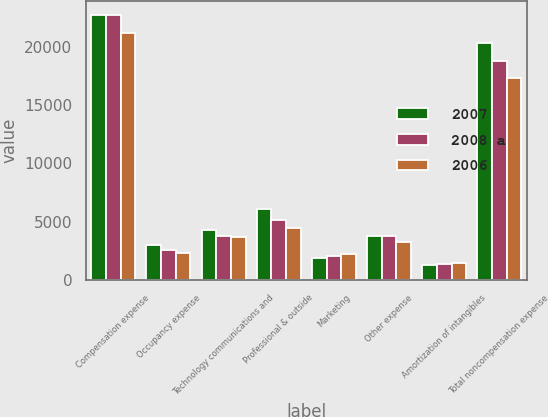Convert chart. <chart><loc_0><loc_0><loc_500><loc_500><stacked_bar_chart><ecel><fcel>Compensation expense<fcel>Occupancy expense<fcel>Technology communications and<fcel>Professional & outside<fcel>Marketing<fcel>Other expense<fcel>Amortization of intangibles<fcel>Total noncompensation expense<nl><fcel>2007<fcel>22746<fcel>3038<fcel>4315<fcel>6053<fcel>1913<fcel>3740<fcel>1263<fcel>20322<nl><fcel>2008 a<fcel>22689<fcel>2608<fcel>3779<fcel>5140<fcel>2070<fcel>3814<fcel>1394<fcel>18805<nl><fcel>2006<fcel>21191<fcel>2335<fcel>3653<fcel>4450<fcel>2209<fcel>3272<fcel>1428<fcel>17347<nl></chart> 